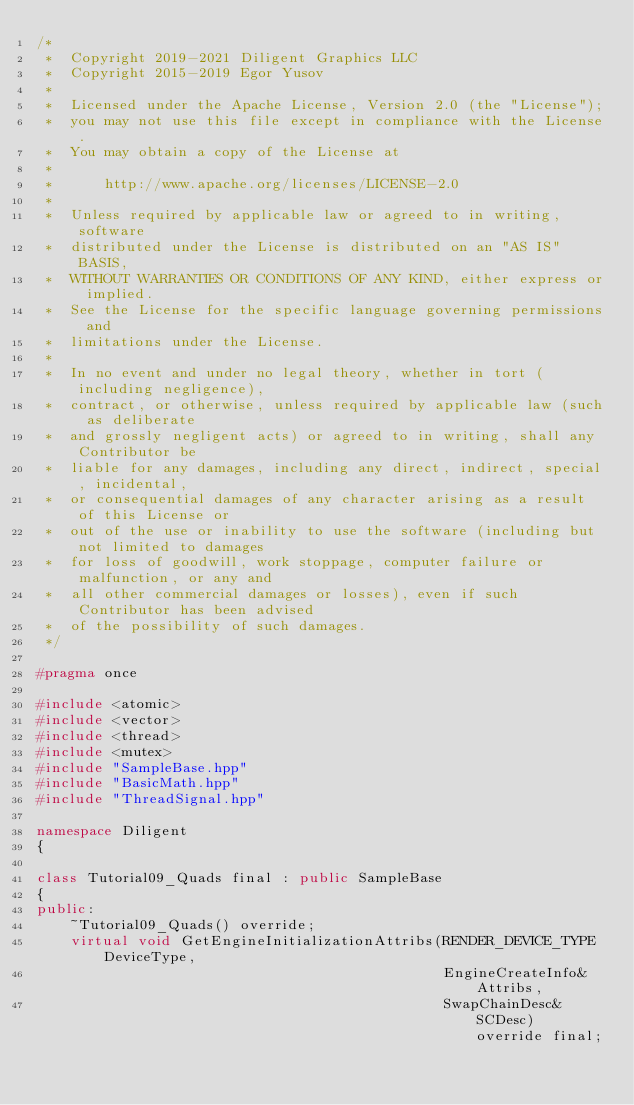Convert code to text. <code><loc_0><loc_0><loc_500><loc_500><_C++_>/*
 *  Copyright 2019-2021 Diligent Graphics LLC
 *  Copyright 2015-2019 Egor Yusov
 *  
 *  Licensed under the Apache License, Version 2.0 (the "License");
 *  you may not use this file except in compliance with the License.
 *  You may obtain a copy of the License at
 *  
 *      http://www.apache.org/licenses/LICENSE-2.0
 *  
 *  Unless required by applicable law or agreed to in writing, software
 *  distributed under the License is distributed on an "AS IS" BASIS,
 *  WITHOUT WARRANTIES OR CONDITIONS OF ANY KIND, either express or implied.
 *  See the License for the specific language governing permissions and
 *  limitations under the License.
 *
 *  In no event and under no legal theory, whether in tort (including negligence), 
 *  contract, or otherwise, unless required by applicable law (such as deliberate 
 *  and grossly negligent acts) or agreed to in writing, shall any Contributor be
 *  liable for any damages, including any direct, indirect, special, incidental, 
 *  or consequential damages of any character arising as a result of this License or 
 *  out of the use or inability to use the software (including but not limited to damages 
 *  for loss of goodwill, work stoppage, computer failure or malfunction, or any and 
 *  all other commercial damages or losses), even if such Contributor has been advised 
 *  of the possibility of such damages.
 */

#pragma once

#include <atomic>
#include <vector>
#include <thread>
#include <mutex>
#include "SampleBase.hpp"
#include "BasicMath.hpp"
#include "ThreadSignal.hpp"

namespace Diligent
{

class Tutorial09_Quads final : public SampleBase
{
public:
    ~Tutorial09_Quads() override;
    virtual void GetEngineInitializationAttribs(RENDER_DEVICE_TYPE DeviceType,
                                                EngineCreateInfo&  Attribs,
                                                SwapChainDesc&     SCDesc) override final;
</code> 